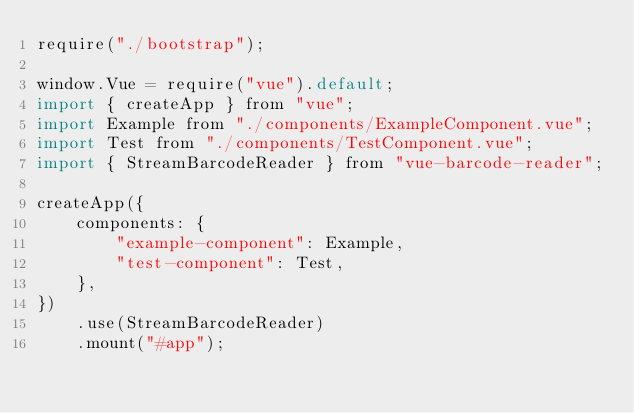<code> <loc_0><loc_0><loc_500><loc_500><_JavaScript_>require("./bootstrap");

window.Vue = require("vue").default;
import { createApp } from "vue";
import Example from "./components/ExampleComponent.vue";
import Test from "./components/TestComponent.vue";
import { StreamBarcodeReader } from "vue-barcode-reader";

createApp({
    components: {
        "example-component": Example,
        "test-component": Test,
    },
})
    .use(StreamBarcodeReader)
    .mount("#app");
</code> 